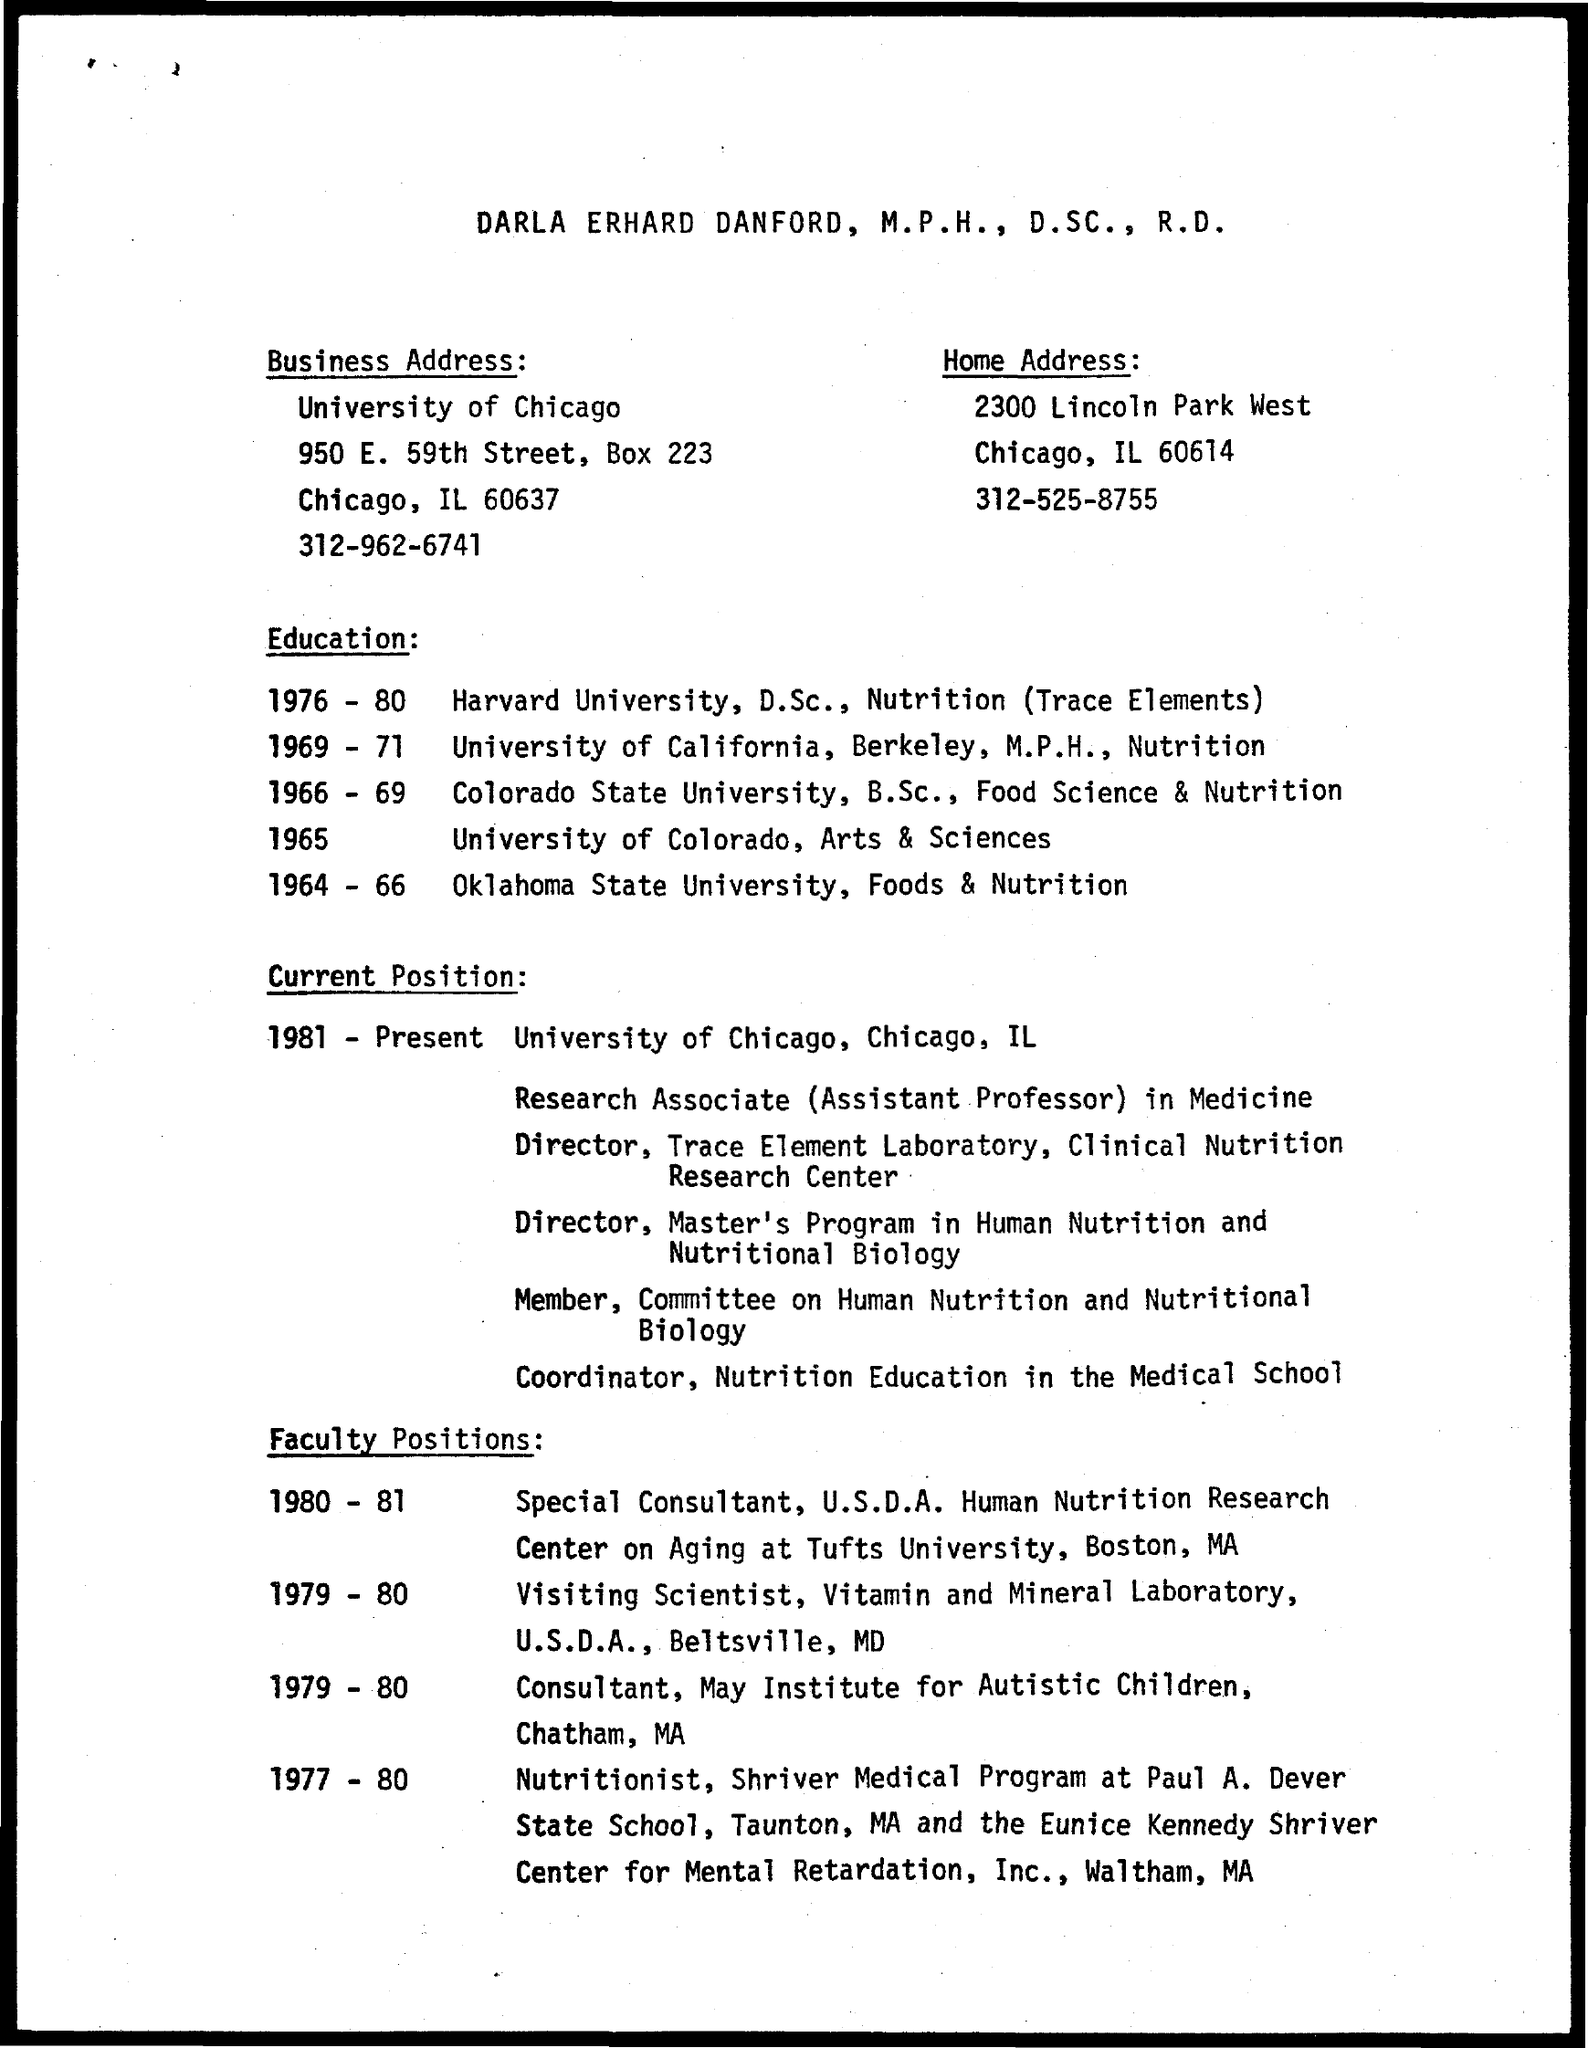What is the name of the university mentioned in the business address ?
Ensure brevity in your answer.  University of chicago. In which university darla erhard danford completed his d.sc nutrition (trace elements) during the years 1976-80 ?
Your answer should be compact. Harvard university. 